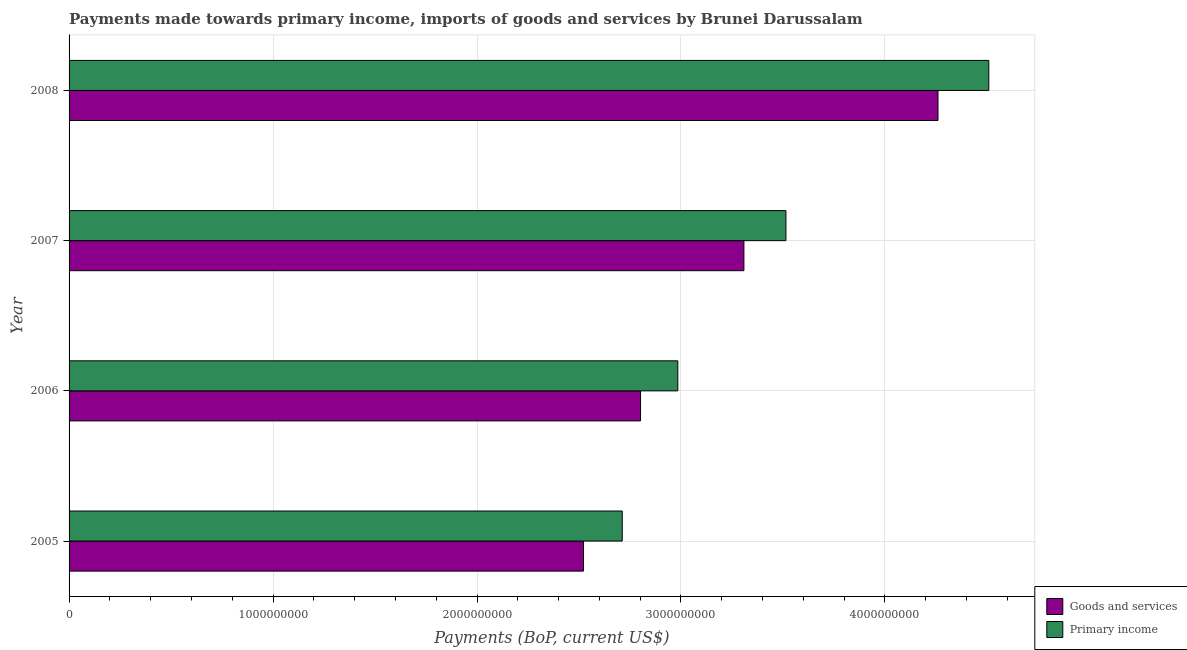How many different coloured bars are there?
Your answer should be compact. 2. How many groups of bars are there?
Your answer should be very brief. 4. Are the number of bars per tick equal to the number of legend labels?
Keep it short and to the point. Yes. Are the number of bars on each tick of the Y-axis equal?
Your answer should be compact. Yes. How many bars are there on the 3rd tick from the bottom?
Your response must be concise. 2. In how many cases, is the number of bars for a given year not equal to the number of legend labels?
Your answer should be compact. 0. What is the payments made towards goods and services in 2006?
Provide a succinct answer. 2.80e+09. Across all years, what is the maximum payments made towards primary income?
Offer a very short reply. 4.51e+09. Across all years, what is the minimum payments made towards goods and services?
Your response must be concise. 2.52e+09. In which year was the payments made towards primary income maximum?
Offer a very short reply. 2008. What is the total payments made towards primary income in the graph?
Your answer should be very brief. 1.37e+1. What is the difference between the payments made towards goods and services in 2005 and that in 2007?
Ensure brevity in your answer.  -7.87e+08. What is the difference between the payments made towards primary income in 2005 and the payments made towards goods and services in 2008?
Provide a succinct answer. -1.55e+09. What is the average payments made towards primary income per year?
Your answer should be compact. 3.43e+09. In the year 2007, what is the difference between the payments made towards goods and services and payments made towards primary income?
Provide a succinct answer. -2.06e+08. What is the ratio of the payments made towards primary income in 2005 to that in 2007?
Keep it short and to the point. 0.77. Is the difference between the payments made towards primary income in 2006 and 2007 greater than the difference between the payments made towards goods and services in 2006 and 2007?
Your answer should be compact. No. What is the difference between the highest and the second highest payments made towards primary income?
Offer a very short reply. 9.95e+08. What is the difference between the highest and the lowest payments made towards goods and services?
Provide a succinct answer. 1.74e+09. In how many years, is the payments made towards primary income greater than the average payments made towards primary income taken over all years?
Offer a terse response. 2. Is the sum of the payments made towards goods and services in 2006 and 2008 greater than the maximum payments made towards primary income across all years?
Your answer should be very brief. Yes. What does the 1st bar from the top in 2008 represents?
Make the answer very short. Primary income. What does the 2nd bar from the bottom in 2005 represents?
Offer a terse response. Primary income. Are all the bars in the graph horizontal?
Ensure brevity in your answer.  Yes. Are the values on the major ticks of X-axis written in scientific E-notation?
Your answer should be compact. No. Does the graph contain grids?
Ensure brevity in your answer.  Yes. How are the legend labels stacked?
Your response must be concise. Vertical. What is the title of the graph?
Give a very brief answer. Payments made towards primary income, imports of goods and services by Brunei Darussalam. Does "Transport services" appear as one of the legend labels in the graph?
Provide a succinct answer. No. What is the label or title of the X-axis?
Offer a terse response. Payments (BoP, current US$). What is the Payments (BoP, current US$) of Goods and services in 2005?
Your response must be concise. 2.52e+09. What is the Payments (BoP, current US$) in Primary income in 2005?
Offer a very short reply. 2.71e+09. What is the Payments (BoP, current US$) in Goods and services in 2006?
Keep it short and to the point. 2.80e+09. What is the Payments (BoP, current US$) in Primary income in 2006?
Your response must be concise. 2.98e+09. What is the Payments (BoP, current US$) of Goods and services in 2007?
Provide a short and direct response. 3.31e+09. What is the Payments (BoP, current US$) in Primary income in 2007?
Make the answer very short. 3.51e+09. What is the Payments (BoP, current US$) of Goods and services in 2008?
Provide a short and direct response. 4.26e+09. What is the Payments (BoP, current US$) in Primary income in 2008?
Your response must be concise. 4.51e+09. Across all years, what is the maximum Payments (BoP, current US$) in Goods and services?
Provide a short and direct response. 4.26e+09. Across all years, what is the maximum Payments (BoP, current US$) of Primary income?
Provide a short and direct response. 4.51e+09. Across all years, what is the minimum Payments (BoP, current US$) in Goods and services?
Provide a succinct answer. 2.52e+09. Across all years, what is the minimum Payments (BoP, current US$) of Primary income?
Provide a short and direct response. 2.71e+09. What is the total Payments (BoP, current US$) in Goods and services in the graph?
Provide a short and direct response. 1.29e+1. What is the total Payments (BoP, current US$) of Primary income in the graph?
Keep it short and to the point. 1.37e+1. What is the difference between the Payments (BoP, current US$) of Goods and services in 2005 and that in 2006?
Provide a short and direct response. -2.80e+08. What is the difference between the Payments (BoP, current US$) in Primary income in 2005 and that in 2006?
Offer a very short reply. -2.72e+08. What is the difference between the Payments (BoP, current US$) in Goods and services in 2005 and that in 2007?
Your answer should be very brief. -7.87e+08. What is the difference between the Payments (BoP, current US$) in Primary income in 2005 and that in 2007?
Offer a terse response. -8.03e+08. What is the difference between the Payments (BoP, current US$) in Goods and services in 2005 and that in 2008?
Offer a terse response. -1.74e+09. What is the difference between the Payments (BoP, current US$) of Primary income in 2005 and that in 2008?
Provide a succinct answer. -1.80e+09. What is the difference between the Payments (BoP, current US$) of Goods and services in 2006 and that in 2007?
Offer a terse response. -5.07e+08. What is the difference between the Payments (BoP, current US$) of Primary income in 2006 and that in 2007?
Keep it short and to the point. -5.30e+08. What is the difference between the Payments (BoP, current US$) of Goods and services in 2006 and that in 2008?
Your answer should be very brief. -1.46e+09. What is the difference between the Payments (BoP, current US$) in Primary income in 2006 and that in 2008?
Your answer should be very brief. -1.52e+09. What is the difference between the Payments (BoP, current US$) of Goods and services in 2007 and that in 2008?
Offer a very short reply. -9.52e+08. What is the difference between the Payments (BoP, current US$) in Primary income in 2007 and that in 2008?
Your answer should be very brief. -9.95e+08. What is the difference between the Payments (BoP, current US$) of Goods and services in 2005 and the Payments (BoP, current US$) of Primary income in 2006?
Offer a terse response. -4.63e+08. What is the difference between the Payments (BoP, current US$) of Goods and services in 2005 and the Payments (BoP, current US$) of Primary income in 2007?
Provide a short and direct response. -9.93e+08. What is the difference between the Payments (BoP, current US$) in Goods and services in 2005 and the Payments (BoP, current US$) in Primary income in 2008?
Offer a very short reply. -1.99e+09. What is the difference between the Payments (BoP, current US$) in Goods and services in 2006 and the Payments (BoP, current US$) in Primary income in 2007?
Make the answer very short. -7.13e+08. What is the difference between the Payments (BoP, current US$) of Goods and services in 2006 and the Payments (BoP, current US$) of Primary income in 2008?
Offer a very short reply. -1.71e+09. What is the difference between the Payments (BoP, current US$) in Goods and services in 2007 and the Payments (BoP, current US$) in Primary income in 2008?
Offer a very short reply. -1.20e+09. What is the average Payments (BoP, current US$) in Goods and services per year?
Your response must be concise. 3.22e+09. What is the average Payments (BoP, current US$) of Primary income per year?
Your answer should be compact. 3.43e+09. In the year 2005, what is the difference between the Payments (BoP, current US$) of Goods and services and Payments (BoP, current US$) of Primary income?
Make the answer very short. -1.90e+08. In the year 2006, what is the difference between the Payments (BoP, current US$) in Goods and services and Payments (BoP, current US$) in Primary income?
Your response must be concise. -1.83e+08. In the year 2007, what is the difference between the Payments (BoP, current US$) in Goods and services and Payments (BoP, current US$) in Primary income?
Ensure brevity in your answer.  -2.06e+08. In the year 2008, what is the difference between the Payments (BoP, current US$) of Goods and services and Payments (BoP, current US$) of Primary income?
Your answer should be very brief. -2.49e+08. What is the ratio of the Payments (BoP, current US$) of Goods and services in 2005 to that in 2006?
Offer a very short reply. 0.9. What is the ratio of the Payments (BoP, current US$) of Primary income in 2005 to that in 2006?
Ensure brevity in your answer.  0.91. What is the ratio of the Payments (BoP, current US$) in Goods and services in 2005 to that in 2007?
Provide a short and direct response. 0.76. What is the ratio of the Payments (BoP, current US$) of Primary income in 2005 to that in 2007?
Your answer should be very brief. 0.77. What is the ratio of the Payments (BoP, current US$) in Goods and services in 2005 to that in 2008?
Make the answer very short. 0.59. What is the ratio of the Payments (BoP, current US$) in Primary income in 2005 to that in 2008?
Give a very brief answer. 0.6. What is the ratio of the Payments (BoP, current US$) of Goods and services in 2006 to that in 2007?
Give a very brief answer. 0.85. What is the ratio of the Payments (BoP, current US$) of Primary income in 2006 to that in 2007?
Make the answer very short. 0.85. What is the ratio of the Payments (BoP, current US$) in Goods and services in 2006 to that in 2008?
Provide a succinct answer. 0.66. What is the ratio of the Payments (BoP, current US$) of Primary income in 2006 to that in 2008?
Keep it short and to the point. 0.66. What is the ratio of the Payments (BoP, current US$) of Goods and services in 2007 to that in 2008?
Make the answer very short. 0.78. What is the ratio of the Payments (BoP, current US$) in Primary income in 2007 to that in 2008?
Your answer should be very brief. 0.78. What is the difference between the highest and the second highest Payments (BoP, current US$) in Goods and services?
Your response must be concise. 9.52e+08. What is the difference between the highest and the second highest Payments (BoP, current US$) in Primary income?
Your answer should be compact. 9.95e+08. What is the difference between the highest and the lowest Payments (BoP, current US$) in Goods and services?
Ensure brevity in your answer.  1.74e+09. What is the difference between the highest and the lowest Payments (BoP, current US$) of Primary income?
Provide a succinct answer. 1.80e+09. 